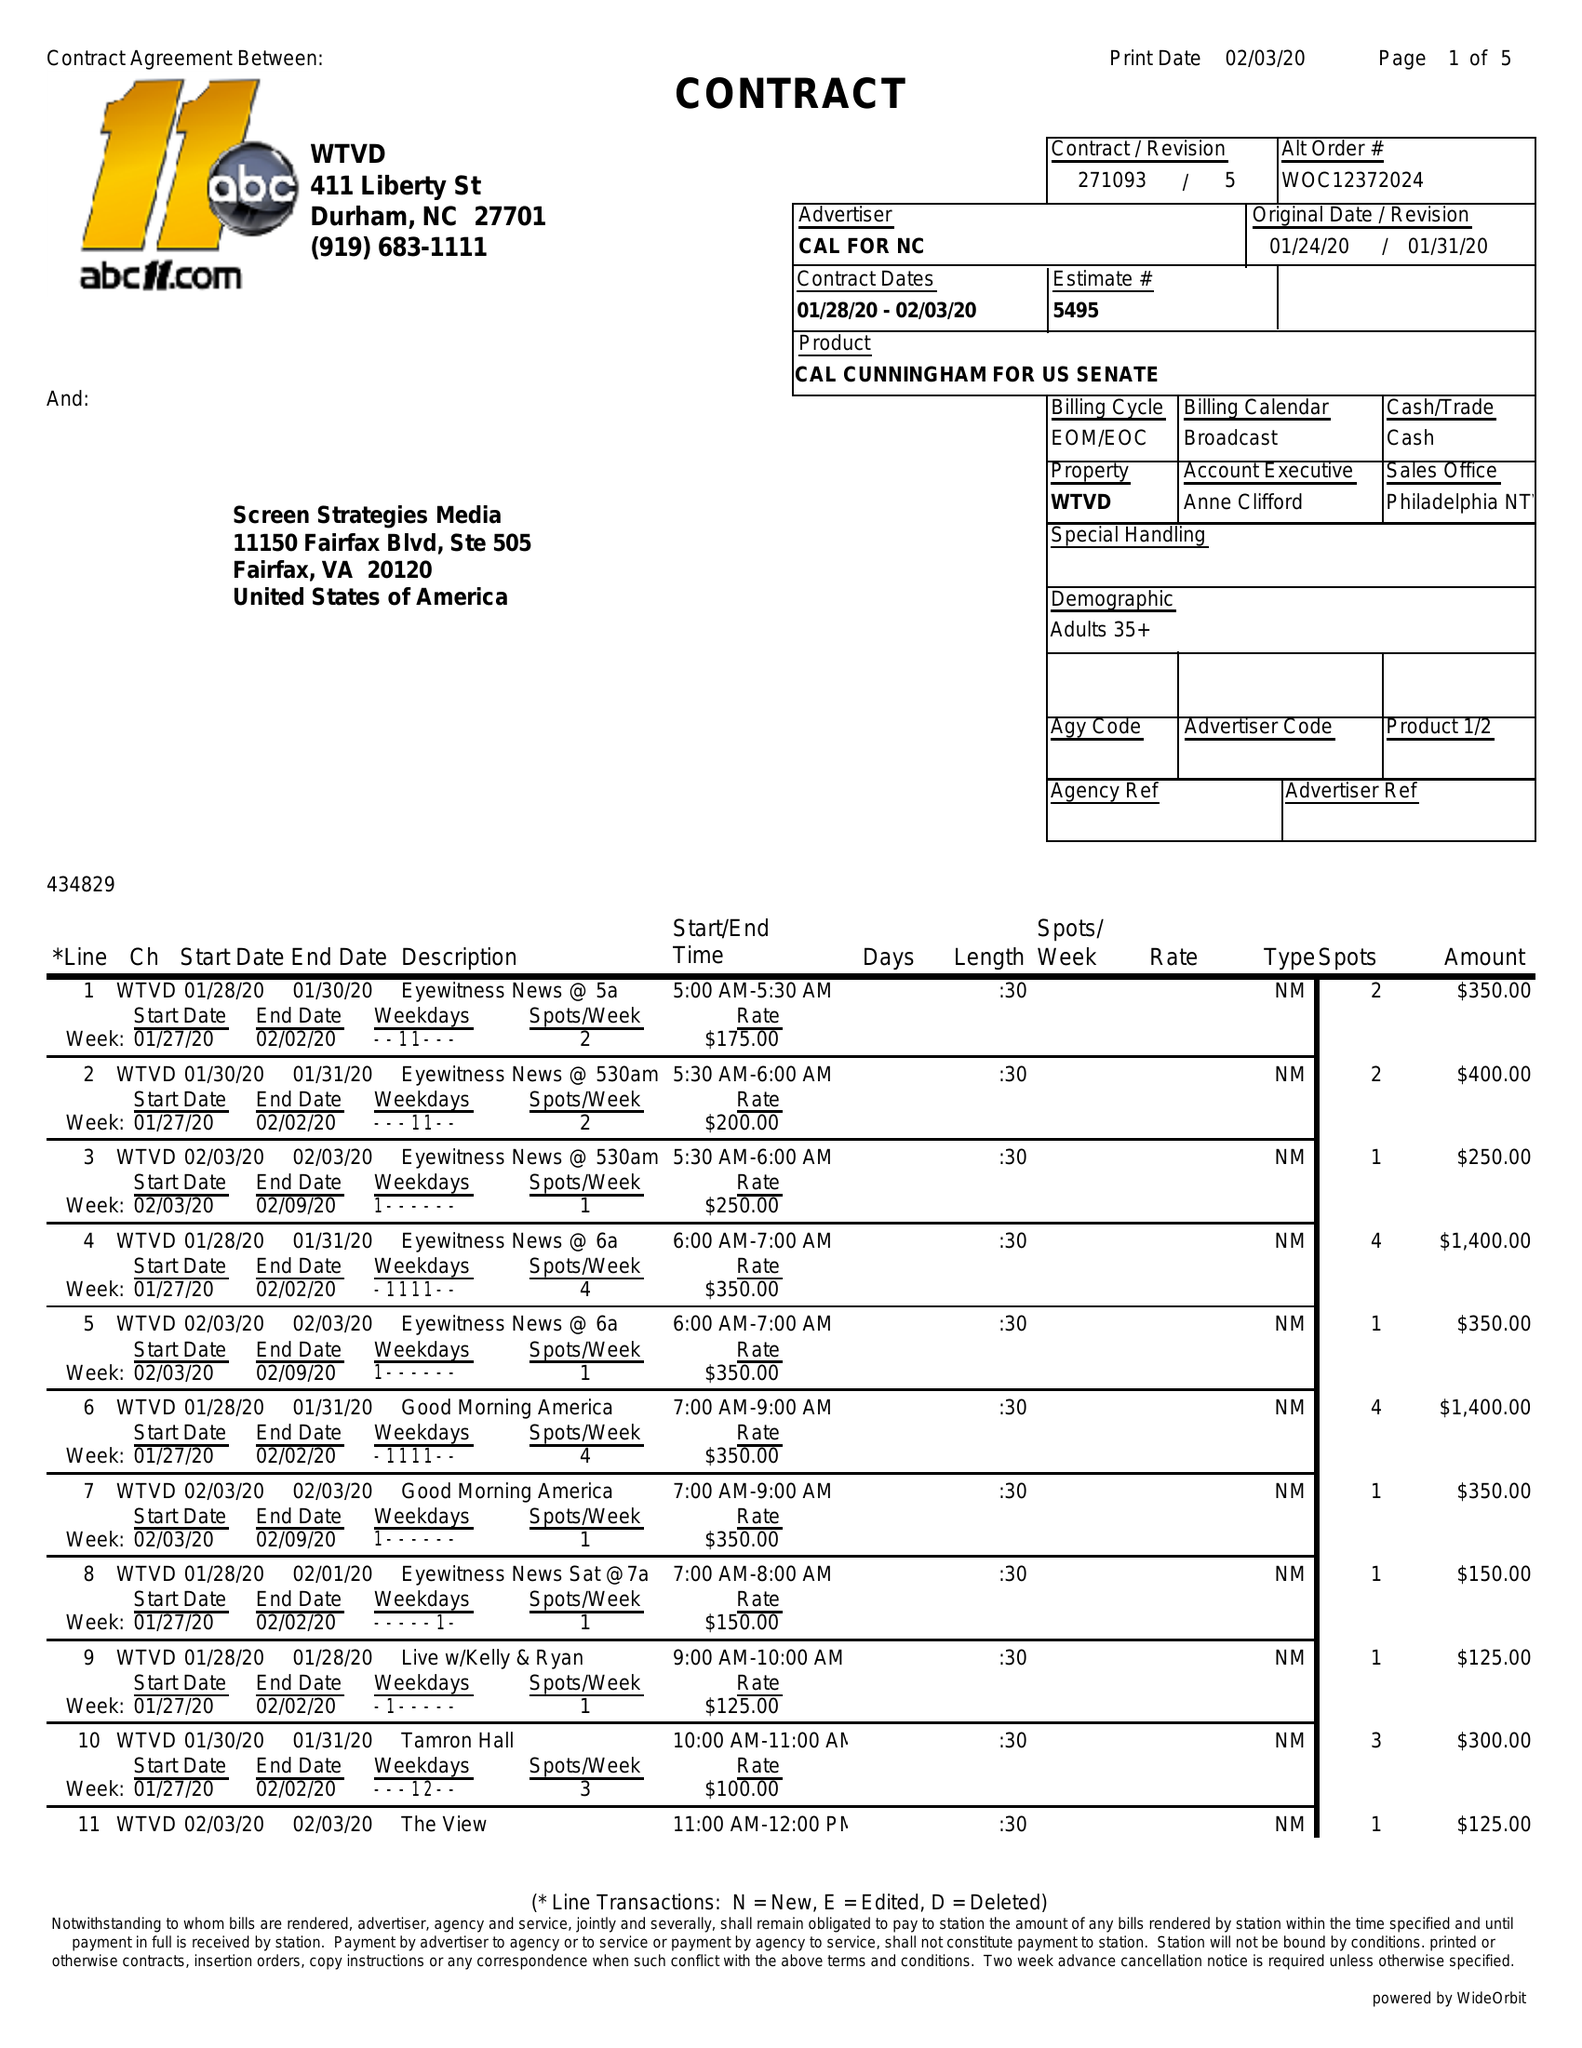What is the value for the contract_num?
Answer the question using a single word or phrase. 271093 